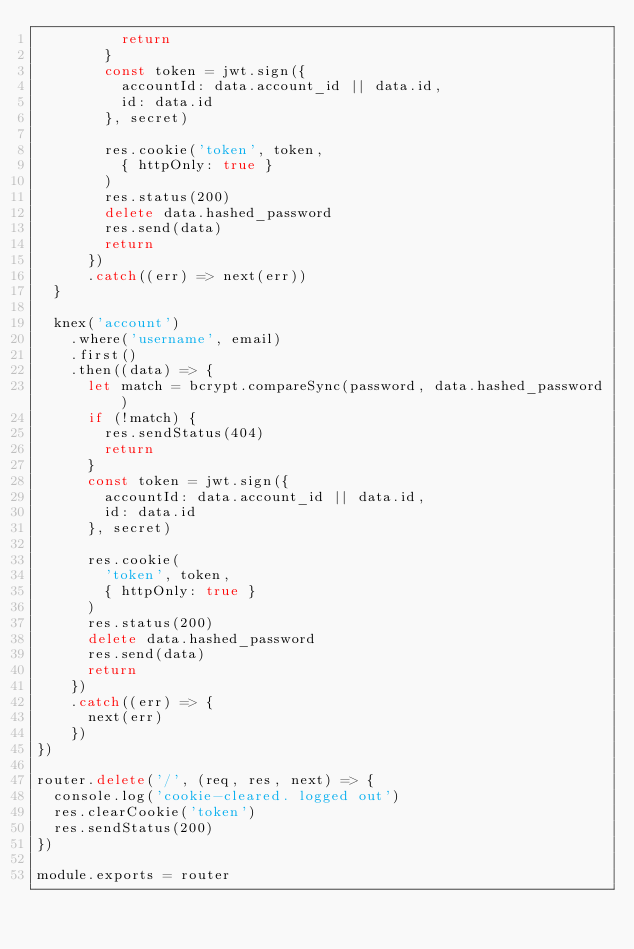<code> <loc_0><loc_0><loc_500><loc_500><_JavaScript_>          return
        }
        const token = jwt.sign({
          accountId: data.account_id || data.id,
          id: data.id
        }, secret)

        res.cookie('token', token,
          { httpOnly: true }
        )
        res.status(200)
        delete data.hashed_password
        res.send(data)
        return
      })
      .catch((err) => next(err))
  }

  knex('account')
    .where('username', email)
    .first()
    .then((data) => {
      let match = bcrypt.compareSync(password, data.hashed_password)
      if (!match) {
        res.sendStatus(404)
        return
      }
      const token = jwt.sign({
        accountId: data.account_id || data.id,
        id: data.id
      }, secret)

      res.cookie(
        'token', token,
        { httpOnly: true }
      )
      res.status(200)
      delete data.hashed_password
      res.send(data)
      return
    })
    .catch((err) => {
      next(err)
    })
})

router.delete('/', (req, res, next) => {
  console.log('cookie-cleared. logged out')
  res.clearCookie('token')
  res.sendStatus(200)
})

module.exports = router
</code> 